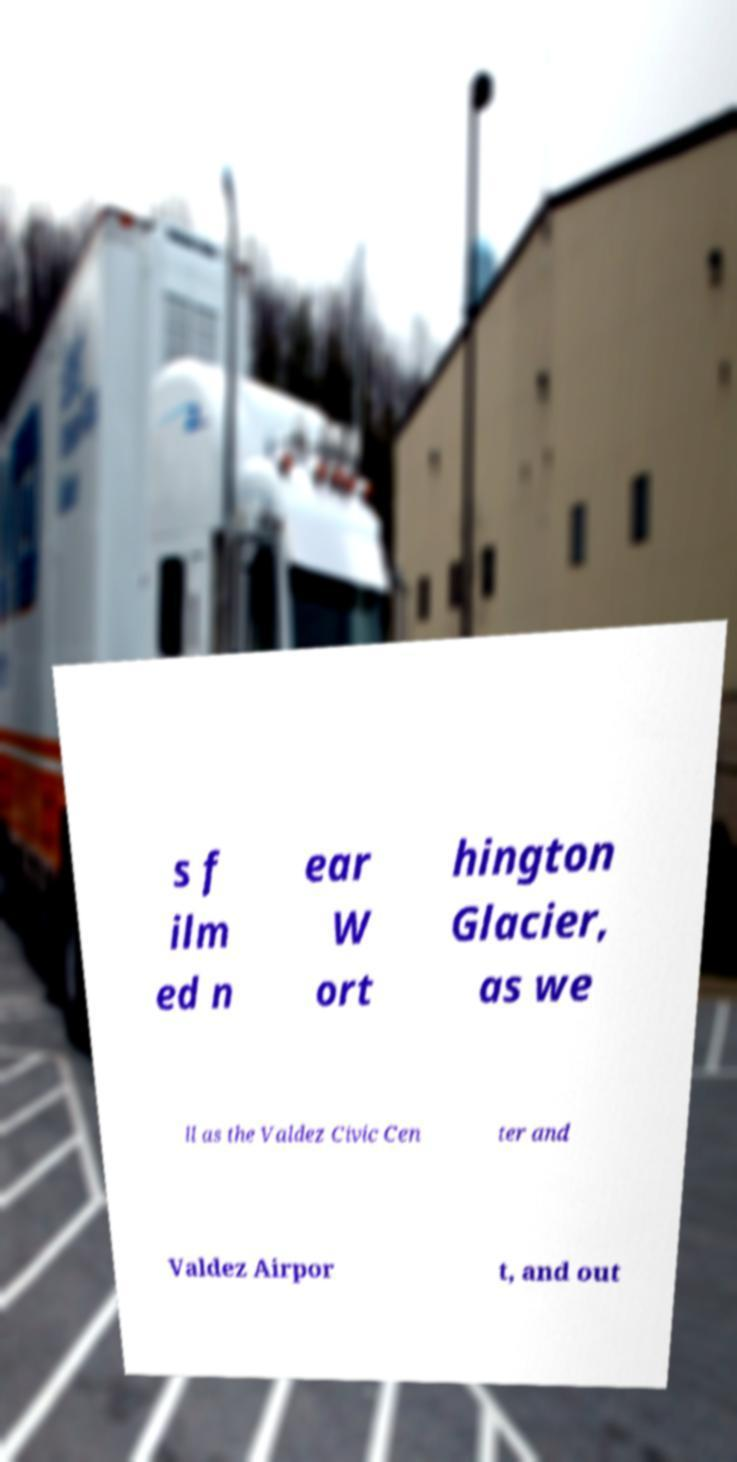There's text embedded in this image that I need extracted. Can you transcribe it verbatim? s f ilm ed n ear W ort hington Glacier, as we ll as the Valdez Civic Cen ter and Valdez Airpor t, and out 